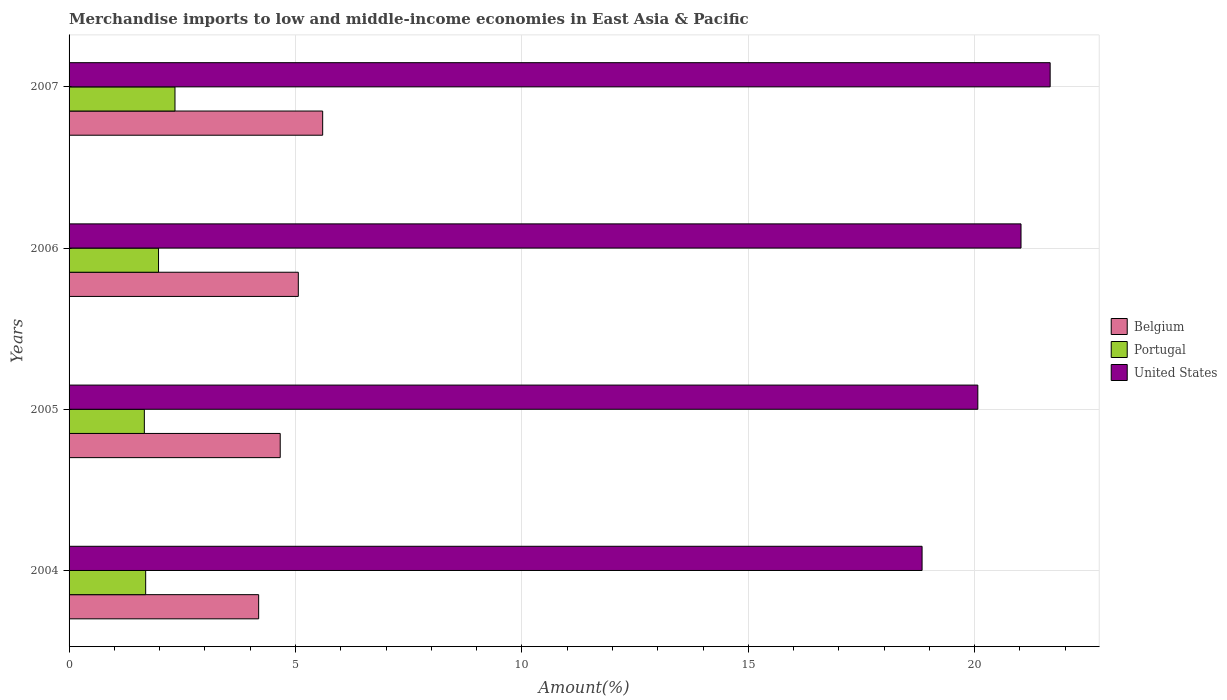How many different coloured bars are there?
Your answer should be compact. 3. How many groups of bars are there?
Ensure brevity in your answer.  4. Are the number of bars on each tick of the Y-axis equal?
Give a very brief answer. Yes. How many bars are there on the 1st tick from the top?
Make the answer very short. 3. How many bars are there on the 2nd tick from the bottom?
Provide a short and direct response. 3. What is the label of the 3rd group of bars from the top?
Give a very brief answer. 2005. In how many cases, is the number of bars for a given year not equal to the number of legend labels?
Offer a terse response. 0. What is the percentage of amount earned from merchandise imports in United States in 2004?
Provide a short and direct response. 18.84. Across all years, what is the maximum percentage of amount earned from merchandise imports in Belgium?
Ensure brevity in your answer.  5.6. Across all years, what is the minimum percentage of amount earned from merchandise imports in Belgium?
Ensure brevity in your answer.  4.19. In which year was the percentage of amount earned from merchandise imports in Belgium maximum?
Make the answer very short. 2007. In which year was the percentage of amount earned from merchandise imports in Portugal minimum?
Offer a very short reply. 2005. What is the total percentage of amount earned from merchandise imports in Portugal in the graph?
Ensure brevity in your answer.  7.67. What is the difference between the percentage of amount earned from merchandise imports in Belgium in 2004 and that in 2006?
Offer a terse response. -0.88. What is the difference between the percentage of amount earned from merchandise imports in United States in 2004 and the percentage of amount earned from merchandise imports in Portugal in 2007?
Provide a succinct answer. 16.5. What is the average percentage of amount earned from merchandise imports in United States per year?
Offer a very short reply. 20.4. In the year 2004, what is the difference between the percentage of amount earned from merchandise imports in Portugal and percentage of amount earned from merchandise imports in United States?
Offer a terse response. -17.15. What is the ratio of the percentage of amount earned from merchandise imports in United States in 2005 to that in 2007?
Your answer should be compact. 0.93. Is the percentage of amount earned from merchandise imports in Portugal in 2004 less than that in 2006?
Give a very brief answer. Yes. Is the difference between the percentage of amount earned from merchandise imports in Portugal in 2004 and 2005 greater than the difference between the percentage of amount earned from merchandise imports in United States in 2004 and 2005?
Give a very brief answer. Yes. What is the difference between the highest and the second highest percentage of amount earned from merchandise imports in Portugal?
Offer a terse response. 0.36. What is the difference between the highest and the lowest percentage of amount earned from merchandise imports in Belgium?
Your response must be concise. 1.41. In how many years, is the percentage of amount earned from merchandise imports in United States greater than the average percentage of amount earned from merchandise imports in United States taken over all years?
Your answer should be very brief. 2. Is the sum of the percentage of amount earned from merchandise imports in Belgium in 2004 and 2006 greater than the maximum percentage of amount earned from merchandise imports in Portugal across all years?
Make the answer very short. Yes. What does the 3rd bar from the top in 2004 represents?
Provide a short and direct response. Belgium. Is it the case that in every year, the sum of the percentage of amount earned from merchandise imports in Portugal and percentage of amount earned from merchandise imports in Belgium is greater than the percentage of amount earned from merchandise imports in United States?
Your response must be concise. No. How many bars are there?
Offer a terse response. 12. Are all the bars in the graph horizontal?
Provide a succinct answer. Yes. Are the values on the major ticks of X-axis written in scientific E-notation?
Your answer should be very brief. No. Does the graph contain any zero values?
Give a very brief answer. No. Does the graph contain grids?
Provide a short and direct response. Yes. Where does the legend appear in the graph?
Provide a short and direct response. Center right. How many legend labels are there?
Provide a succinct answer. 3. What is the title of the graph?
Keep it short and to the point. Merchandise imports to low and middle-income economies in East Asia & Pacific. What is the label or title of the X-axis?
Keep it short and to the point. Amount(%). What is the label or title of the Y-axis?
Ensure brevity in your answer.  Years. What is the Amount(%) of Belgium in 2004?
Give a very brief answer. 4.19. What is the Amount(%) of Portugal in 2004?
Offer a very short reply. 1.69. What is the Amount(%) in United States in 2004?
Ensure brevity in your answer.  18.84. What is the Amount(%) in Belgium in 2005?
Your answer should be compact. 4.66. What is the Amount(%) in Portugal in 2005?
Provide a succinct answer. 1.66. What is the Amount(%) in United States in 2005?
Offer a very short reply. 20.07. What is the Amount(%) of Belgium in 2006?
Provide a short and direct response. 5.06. What is the Amount(%) in Portugal in 2006?
Give a very brief answer. 1.98. What is the Amount(%) in United States in 2006?
Provide a succinct answer. 21.02. What is the Amount(%) in Belgium in 2007?
Offer a terse response. 5.6. What is the Amount(%) of Portugal in 2007?
Ensure brevity in your answer.  2.34. What is the Amount(%) of United States in 2007?
Provide a short and direct response. 21.67. Across all years, what is the maximum Amount(%) of Belgium?
Provide a short and direct response. 5.6. Across all years, what is the maximum Amount(%) of Portugal?
Keep it short and to the point. 2.34. Across all years, what is the maximum Amount(%) of United States?
Your answer should be compact. 21.67. Across all years, what is the minimum Amount(%) in Belgium?
Ensure brevity in your answer.  4.19. Across all years, what is the minimum Amount(%) in Portugal?
Provide a short and direct response. 1.66. Across all years, what is the minimum Amount(%) in United States?
Your answer should be very brief. 18.84. What is the total Amount(%) of Belgium in the graph?
Give a very brief answer. 19.51. What is the total Amount(%) of Portugal in the graph?
Ensure brevity in your answer.  7.67. What is the total Amount(%) of United States in the graph?
Make the answer very short. 81.6. What is the difference between the Amount(%) of Belgium in 2004 and that in 2005?
Provide a succinct answer. -0.48. What is the difference between the Amount(%) of Portugal in 2004 and that in 2005?
Offer a terse response. 0.03. What is the difference between the Amount(%) in United States in 2004 and that in 2005?
Make the answer very short. -1.23. What is the difference between the Amount(%) in Belgium in 2004 and that in 2006?
Provide a short and direct response. -0.88. What is the difference between the Amount(%) of Portugal in 2004 and that in 2006?
Your response must be concise. -0.28. What is the difference between the Amount(%) of United States in 2004 and that in 2006?
Give a very brief answer. -2.19. What is the difference between the Amount(%) in Belgium in 2004 and that in 2007?
Make the answer very short. -1.41. What is the difference between the Amount(%) of Portugal in 2004 and that in 2007?
Ensure brevity in your answer.  -0.65. What is the difference between the Amount(%) in United States in 2004 and that in 2007?
Provide a short and direct response. -2.83. What is the difference between the Amount(%) in Belgium in 2005 and that in 2006?
Your answer should be very brief. -0.4. What is the difference between the Amount(%) of Portugal in 2005 and that in 2006?
Ensure brevity in your answer.  -0.31. What is the difference between the Amount(%) in United States in 2005 and that in 2006?
Keep it short and to the point. -0.95. What is the difference between the Amount(%) of Belgium in 2005 and that in 2007?
Give a very brief answer. -0.94. What is the difference between the Amount(%) in Portugal in 2005 and that in 2007?
Ensure brevity in your answer.  -0.68. What is the difference between the Amount(%) in United States in 2005 and that in 2007?
Keep it short and to the point. -1.6. What is the difference between the Amount(%) of Belgium in 2006 and that in 2007?
Your answer should be very brief. -0.54. What is the difference between the Amount(%) in Portugal in 2006 and that in 2007?
Make the answer very short. -0.36. What is the difference between the Amount(%) in United States in 2006 and that in 2007?
Your response must be concise. -0.64. What is the difference between the Amount(%) in Belgium in 2004 and the Amount(%) in Portugal in 2005?
Keep it short and to the point. 2.52. What is the difference between the Amount(%) in Belgium in 2004 and the Amount(%) in United States in 2005?
Give a very brief answer. -15.88. What is the difference between the Amount(%) in Portugal in 2004 and the Amount(%) in United States in 2005?
Offer a terse response. -18.38. What is the difference between the Amount(%) of Belgium in 2004 and the Amount(%) of Portugal in 2006?
Give a very brief answer. 2.21. What is the difference between the Amount(%) in Belgium in 2004 and the Amount(%) in United States in 2006?
Give a very brief answer. -16.84. What is the difference between the Amount(%) of Portugal in 2004 and the Amount(%) of United States in 2006?
Give a very brief answer. -19.33. What is the difference between the Amount(%) of Belgium in 2004 and the Amount(%) of Portugal in 2007?
Offer a very short reply. 1.85. What is the difference between the Amount(%) of Belgium in 2004 and the Amount(%) of United States in 2007?
Give a very brief answer. -17.48. What is the difference between the Amount(%) of Portugal in 2004 and the Amount(%) of United States in 2007?
Provide a succinct answer. -19.97. What is the difference between the Amount(%) of Belgium in 2005 and the Amount(%) of Portugal in 2006?
Your answer should be very brief. 2.69. What is the difference between the Amount(%) in Belgium in 2005 and the Amount(%) in United States in 2006?
Offer a terse response. -16.36. What is the difference between the Amount(%) in Portugal in 2005 and the Amount(%) in United States in 2006?
Your answer should be very brief. -19.36. What is the difference between the Amount(%) in Belgium in 2005 and the Amount(%) in Portugal in 2007?
Give a very brief answer. 2.32. What is the difference between the Amount(%) of Belgium in 2005 and the Amount(%) of United States in 2007?
Your response must be concise. -17. What is the difference between the Amount(%) of Portugal in 2005 and the Amount(%) of United States in 2007?
Offer a very short reply. -20. What is the difference between the Amount(%) of Belgium in 2006 and the Amount(%) of Portugal in 2007?
Offer a terse response. 2.72. What is the difference between the Amount(%) in Belgium in 2006 and the Amount(%) in United States in 2007?
Your response must be concise. -16.6. What is the difference between the Amount(%) of Portugal in 2006 and the Amount(%) of United States in 2007?
Your answer should be compact. -19.69. What is the average Amount(%) in Belgium per year?
Give a very brief answer. 4.88. What is the average Amount(%) of Portugal per year?
Your answer should be compact. 1.92. What is the average Amount(%) in United States per year?
Offer a very short reply. 20.4. In the year 2004, what is the difference between the Amount(%) of Belgium and Amount(%) of Portugal?
Your answer should be compact. 2.5. In the year 2004, what is the difference between the Amount(%) in Belgium and Amount(%) in United States?
Offer a very short reply. -14.65. In the year 2004, what is the difference between the Amount(%) in Portugal and Amount(%) in United States?
Your response must be concise. -17.15. In the year 2005, what is the difference between the Amount(%) of Belgium and Amount(%) of Portugal?
Offer a terse response. 3. In the year 2005, what is the difference between the Amount(%) in Belgium and Amount(%) in United States?
Keep it short and to the point. -15.41. In the year 2005, what is the difference between the Amount(%) of Portugal and Amount(%) of United States?
Provide a succinct answer. -18.41. In the year 2006, what is the difference between the Amount(%) of Belgium and Amount(%) of Portugal?
Ensure brevity in your answer.  3.09. In the year 2006, what is the difference between the Amount(%) in Belgium and Amount(%) in United States?
Offer a very short reply. -15.96. In the year 2006, what is the difference between the Amount(%) in Portugal and Amount(%) in United States?
Your answer should be very brief. -19.05. In the year 2007, what is the difference between the Amount(%) of Belgium and Amount(%) of Portugal?
Your response must be concise. 3.26. In the year 2007, what is the difference between the Amount(%) of Belgium and Amount(%) of United States?
Provide a succinct answer. -16.07. In the year 2007, what is the difference between the Amount(%) in Portugal and Amount(%) in United States?
Offer a terse response. -19.33. What is the ratio of the Amount(%) of Belgium in 2004 to that in 2005?
Offer a terse response. 0.9. What is the ratio of the Amount(%) of Portugal in 2004 to that in 2005?
Your answer should be very brief. 1.02. What is the ratio of the Amount(%) of United States in 2004 to that in 2005?
Keep it short and to the point. 0.94. What is the ratio of the Amount(%) of Belgium in 2004 to that in 2006?
Ensure brevity in your answer.  0.83. What is the ratio of the Amount(%) in Portugal in 2004 to that in 2006?
Offer a very short reply. 0.86. What is the ratio of the Amount(%) in United States in 2004 to that in 2006?
Keep it short and to the point. 0.9. What is the ratio of the Amount(%) in Belgium in 2004 to that in 2007?
Give a very brief answer. 0.75. What is the ratio of the Amount(%) of Portugal in 2004 to that in 2007?
Ensure brevity in your answer.  0.72. What is the ratio of the Amount(%) in United States in 2004 to that in 2007?
Make the answer very short. 0.87. What is the ratio of the Amount(%) in Belgium in 2005 to that in 2006?
Give a very brief answer. 0.92. What is the ratio of the Amount(%) of Portugal in 2005 to that in 2006?
Give a very brief answer. 0.84. What is the ratio of the Amount(%) in United States in 2005 to that in 2006?
Give a very brief answer. 0.95. What is the ratio of the Amount(%) in Belgium in 2005 to that in 2007?
Your answer should be very brief. 0.83. What is the ratio of the Amount(%) of Portugal in 2005 to that in 2007?
Ensure brevity in your answer.  0.71. What is the ratio of the Amount(%) in United States in 2005 to that in 2007?
Offer a very short reply. 0.93. What is the ratio of the Amount(%) in Belgium in 2006 to that in 2007?
Make the answer very short. 0.9. What is the ratio of the Amount(%) in Portugal in 2006 to that in 2007?
Provide a succinct answer. 0.84. What is the ratio of the Amount(%) in United States in 2006 to that in 2007?
Give a very brief answer. 0.97. What is the difference between the highest and the second highest Amount(%) of Belgium?
Offer a terse response. 0.54. What is the difference between the highest and the second highest Amount(%) in Portugal?
Offer a very short reply. 0.36. What is the difference between the highest and the second highest Amount(%) of United States?
Keep it short and to the point. 0.64. What is the difference between the highest and the lowest Amount(%) in Belgium?
Your response must be concise. 1.41. What is the difference between the highest and the lowest Amount(%) in Portugal?
Make the answer very short. 0.68. What is the difference between the highest and the lowest Amount(%) in United States?
Give a very brief answer. 2.83. 